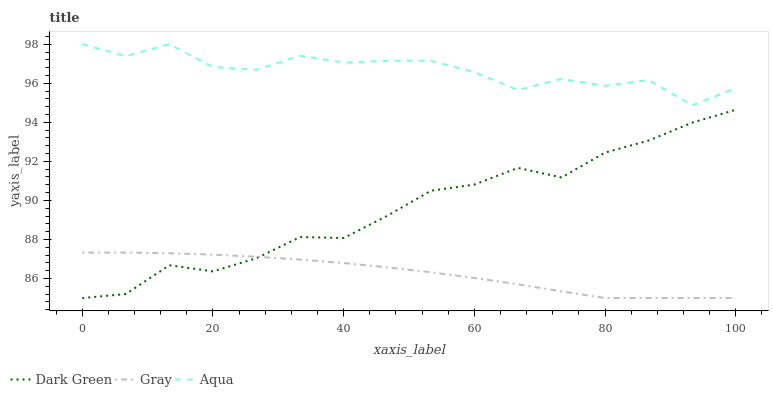Does Gray have the minimum area under the curve?
Answer yes or no. Yes. Does Aqua have the maximum area under the curve?
Answer yes or no. Yes. Does Dark Green have the minimum area under the curve?
Answer yes or no. No. Does Dark Green have the maximum area under the curve?
Answer yes or no. No. Is Gray the smoothest?
Answer yes or no. Yes. Is Aqua the roughest?
Answer yes or no. Yes. Is Dark Green the smoothest?
Answer yes or no. No. Is Dark Green the roughest?
Answer yes or no. No. Does Gray have the lowest value?
Answer yes or no. Yes. Does Aqua have the lowest value?
Answer yes or no. No. Does Aqua have the highest value?
Answer yes or no. Yes. Does Dark Green have the highest value?
Answer yes or no. No. Is Gray less than Aqua?
Answer yes or no. Yes. Is Aqua greater than Dark Green?
Answer yes or no. Yes. Does Dark Green intersect Gray?
Answer yes or no. Yes. Is Dark Green less than Gray?
Answer yes or no. No. Is Dark Green greater than Gray?
Answer yes or no. No. Does Gray intersect Aqua?
Answer yes or no. No. 